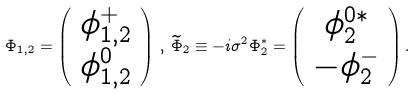Convert formula to latex. <formula><loc_0><loc_0><loc_500><loc_500>\Phi _ { 1 , 2 } = \left ( \begin{array} { c } \phi _ { 1 , 2 } ^ { + } \\ \phi _ { 1 , 2 } ^ { 0 } \end{array} \right ) \, , \, \widetilde { \Phi } _ { 2 } \equiv - i \sigma ^ { 2 } \Phi _ { 2 } ^ { * } = \left ( \begin{array} { c } \phi _ { 2 } ^ { 0 * } \\ - \phi _ { 2 } ^ { - } \end{array} \right ) .</formula> 